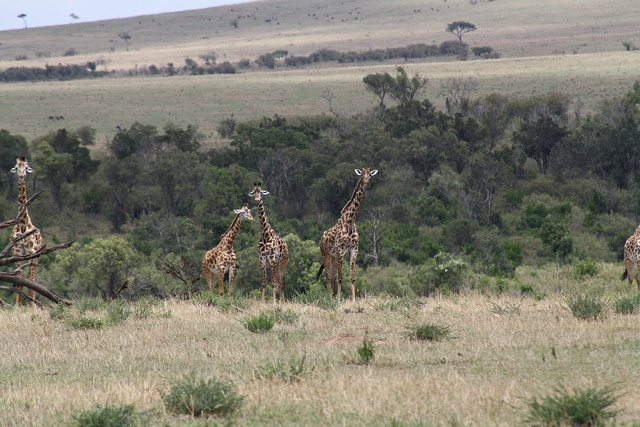Describe the objects in this image and their specific colors. I can see giraffe in lavender, gray, black, and maroon tones, giraffe in lavender, gray, black, and darkgray tones, giraffe in lavender, gray, black, and darkgray tones, giraffe in lavender, gray, maroon, and darkgray tones, and giraffe in lavender, gray, and darkgray tones in this image. 